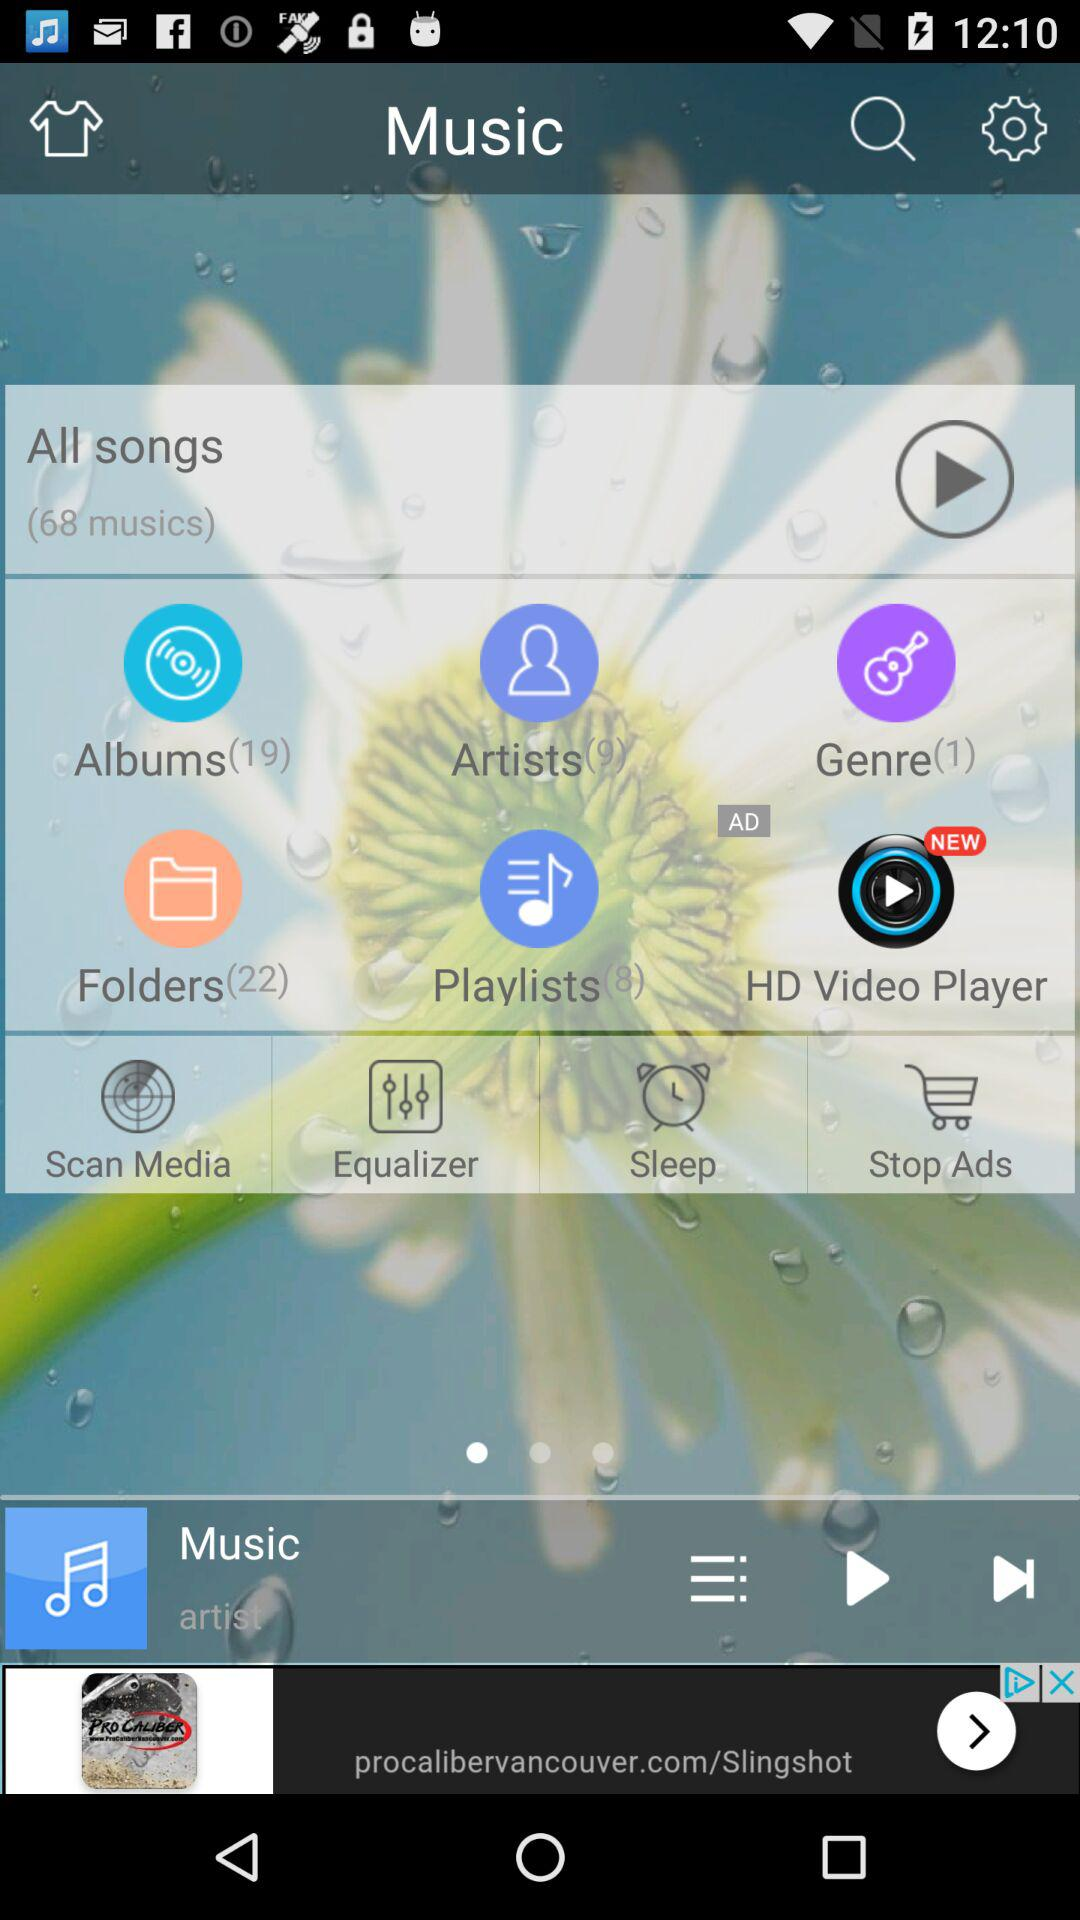What is the number of folders? The number of folders is 22. 